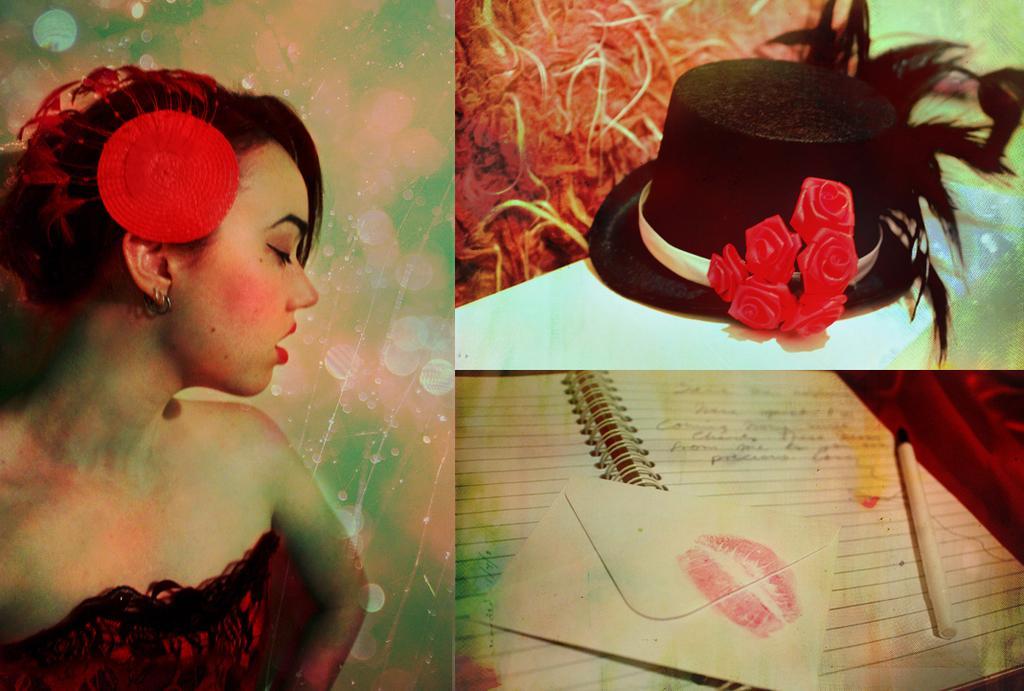Describe this image in one or two sentences. This is a collage image. On the left side of the image there is a woman. At the top right corner of the image there is a hat with roses. At the bottom right corner of the image there is an envelope, a book and a pen. 